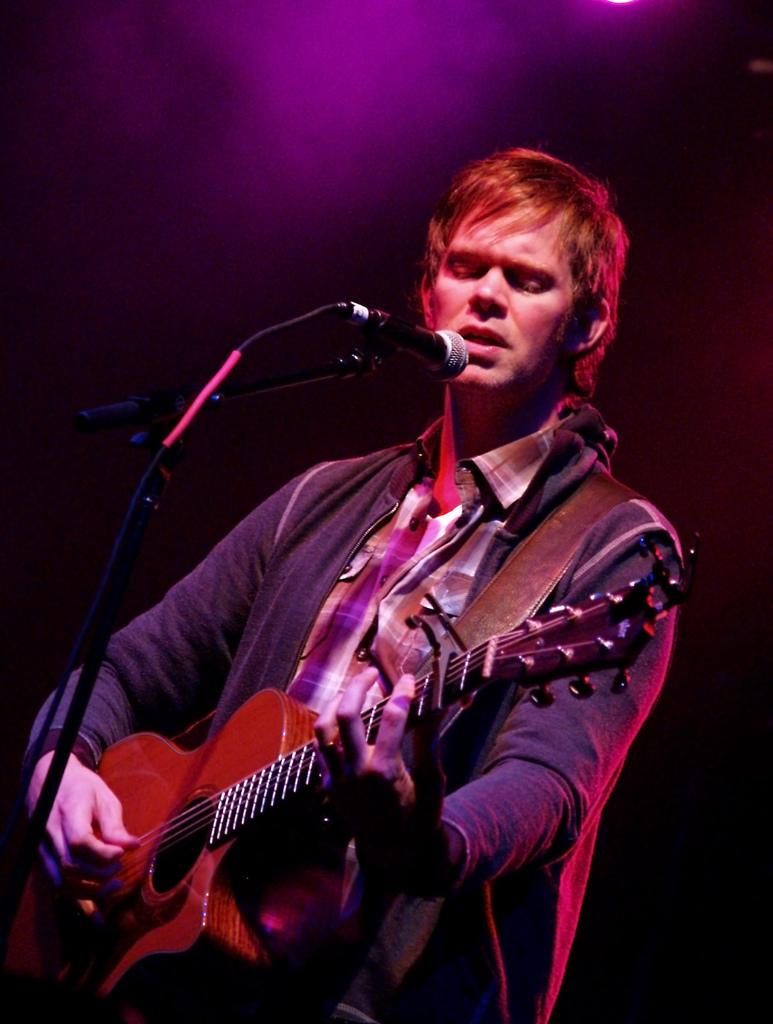What is the main subject of the image? The main subject of the image is a man. What is the man doing in the image? The man is standing, holding a guitar, and playing it. What is the man standing in front of? The man is standing in front of a microphone. What is the man doing with his mouth in the image? The man has opened his mouth for singing. What type of cactus can be seen in the background of the image? There is no cactus present in the image; it features a man playing a guitar in front of a microphone. 